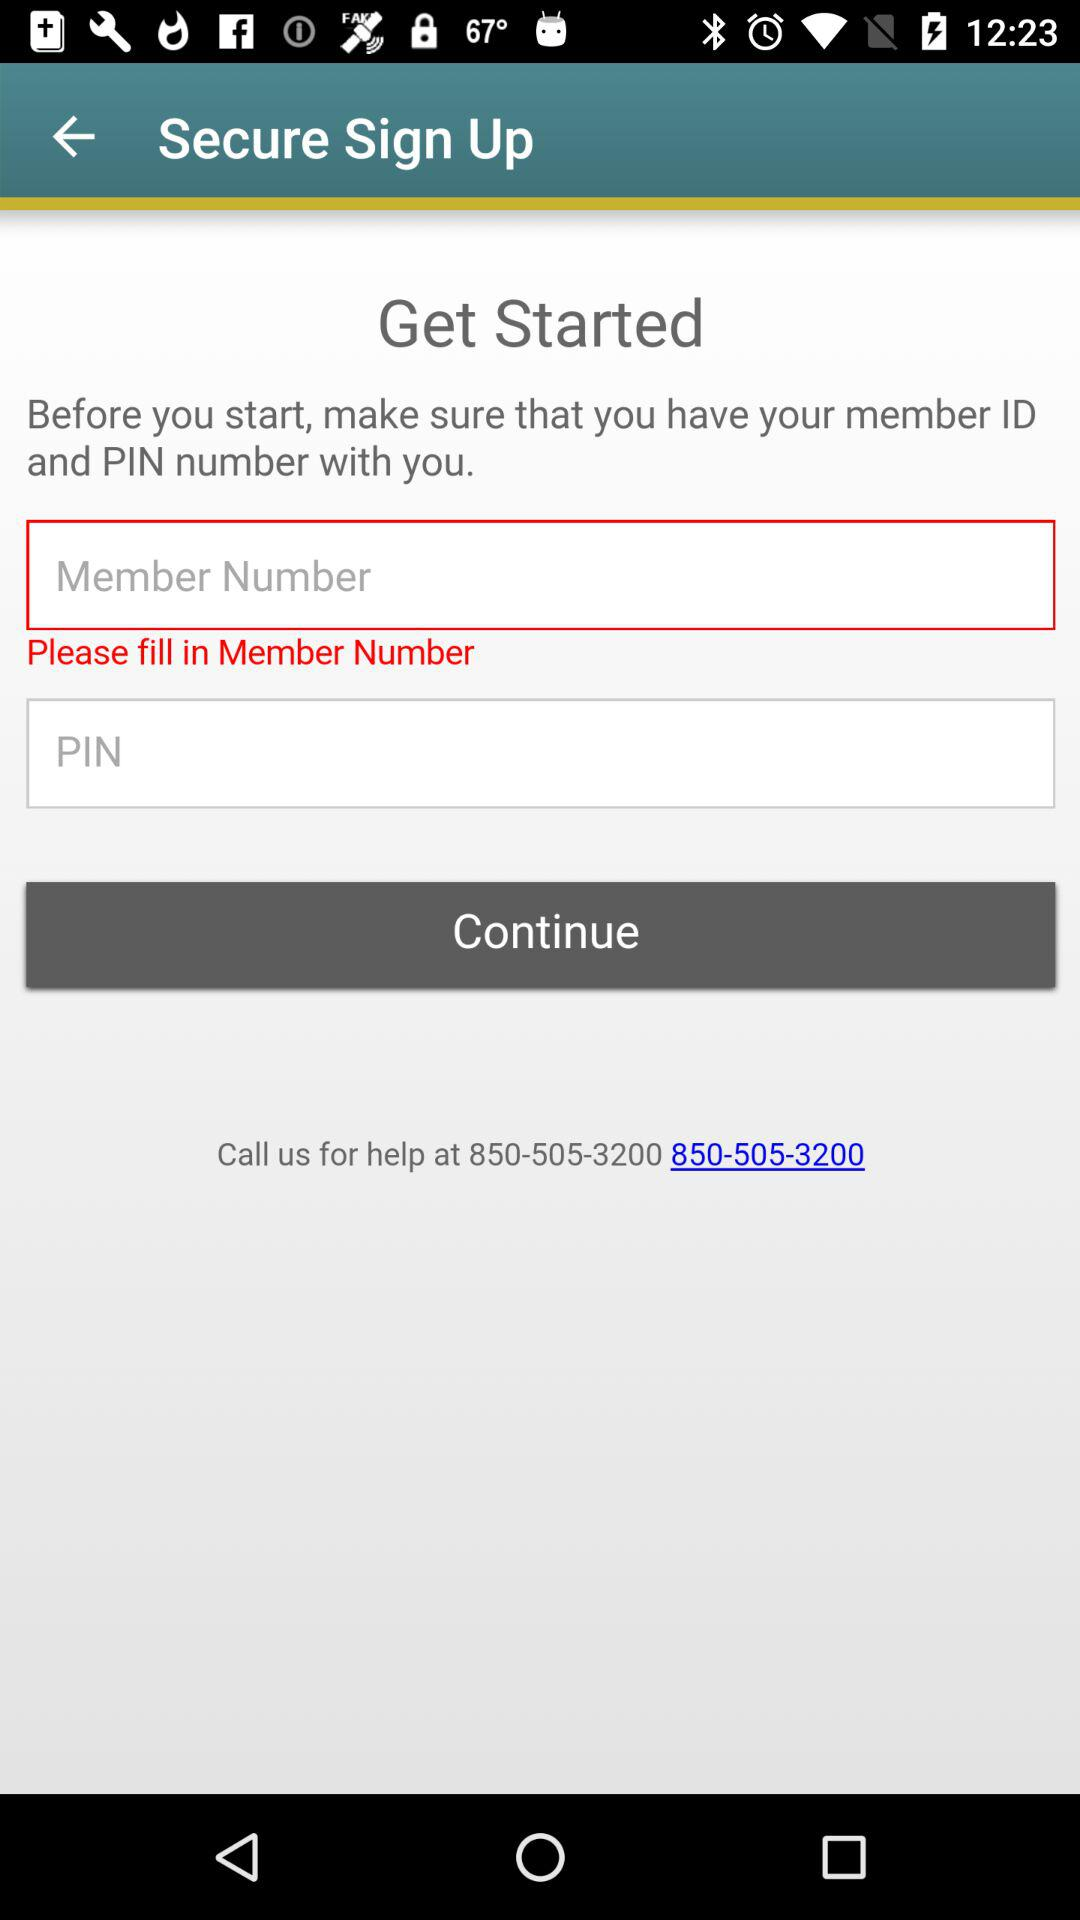What is the contact number that I can call for help? The contact number that you can call for help is 850-505-3200. 